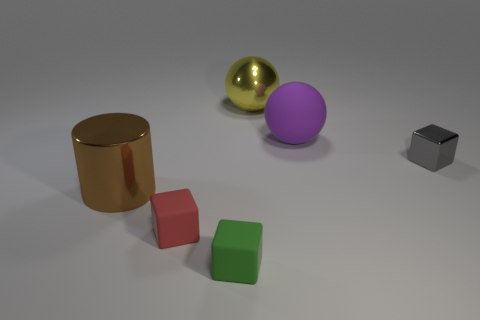Add 2 green objects. How many objects exist? 8 Subtract all rubber cubes. How many cubes are left? 1 Subtract 3 cubes. How many cubes are left? 0 Subtract all yellow balls. Subtract all brown blocks. How many balls are left? 1 Subtract all red cylinders. How many red blocks are left? 1 Subtract all large yellow cylinders. Subtract all yellow metal things. How many objects are left? 5 Add 2 large matte spheres. How many large matte spheres are left? 3 Add 6 brown metal cylinders. How many brown metal cylinders exist? 7 Subtract all red blocks. How many blocks are left? 2 Subtract 0 red balls. How many objects are left? 6 